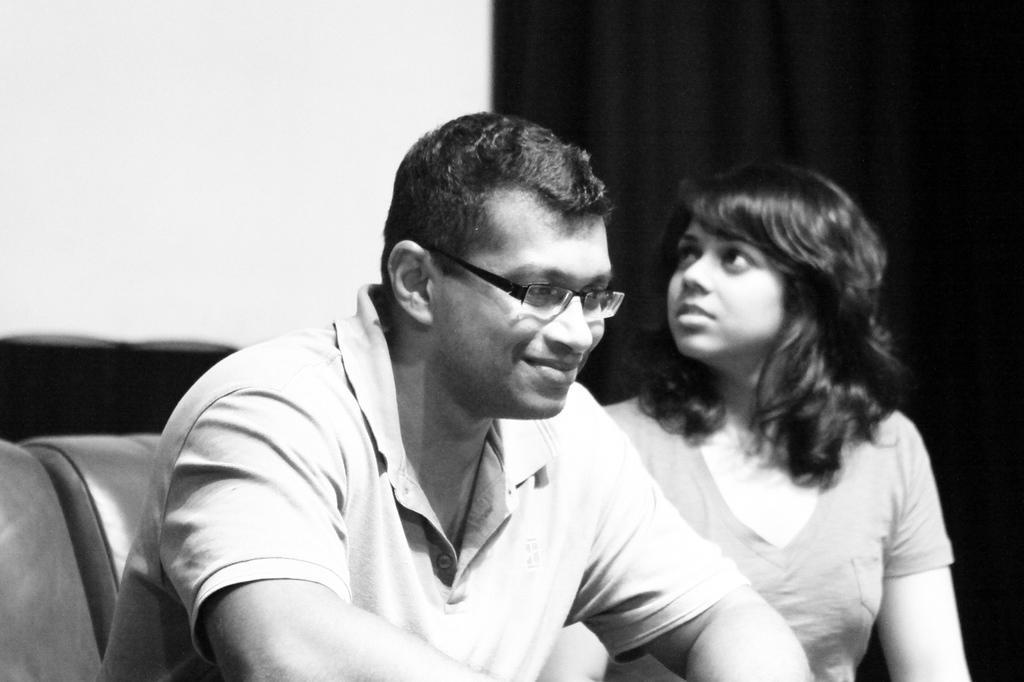Describe this image in one or two sentences. In this image I can see there is a man and a woman sitting on the couch and the man is wearing spectacles and the woman is looking at the left side, there is a wall in the backdrop, there is a curtain at the right side. 